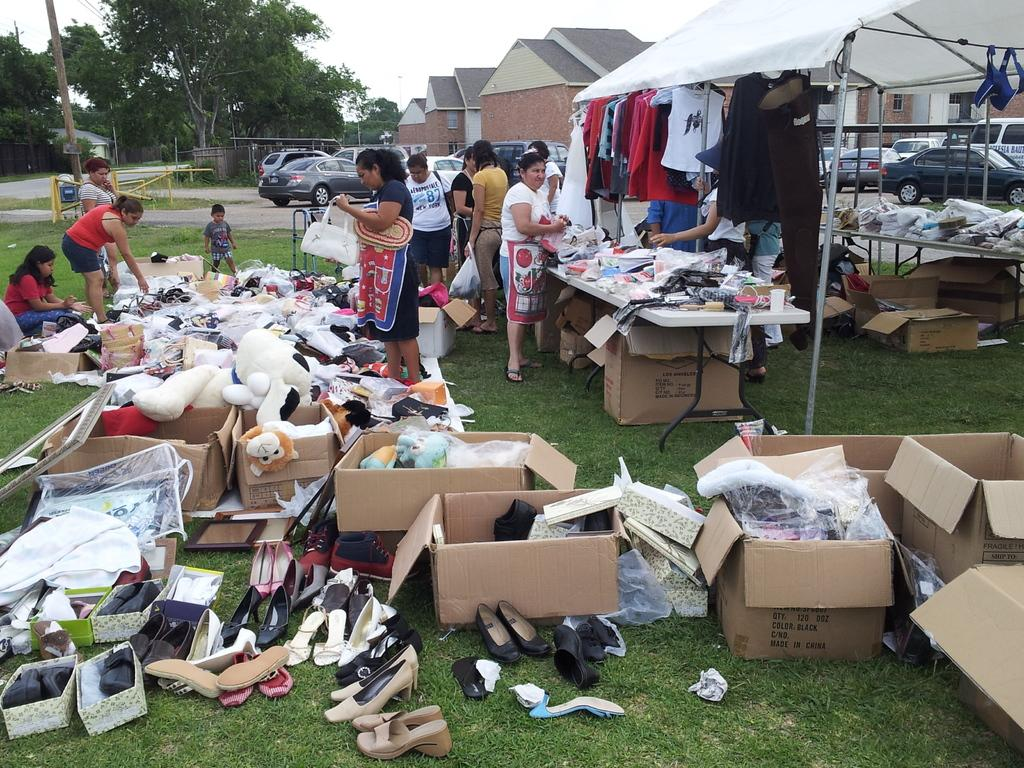How many people are in the image? There is a group of people in the image, but the exact number is not specified. What are the people standing near in the image? The people are standing near a tent in the image. What items can be found inside the tent? The tent contains clothes, toys, and shoes. What type of vehicles can be seen in the image? Cars are visible in the image. What type of buildings can be seen in the image? There are houses in the image. What type of vegetation is present in the image? Trees are present in the image. What is the condition of the sky in the image? The sky is clear in the image. What type of meat is being served at the brothers' gathering in the image? There is no mention of meat or brothers in the image; it features a group of people standing near a tent with a variety of items inside. 